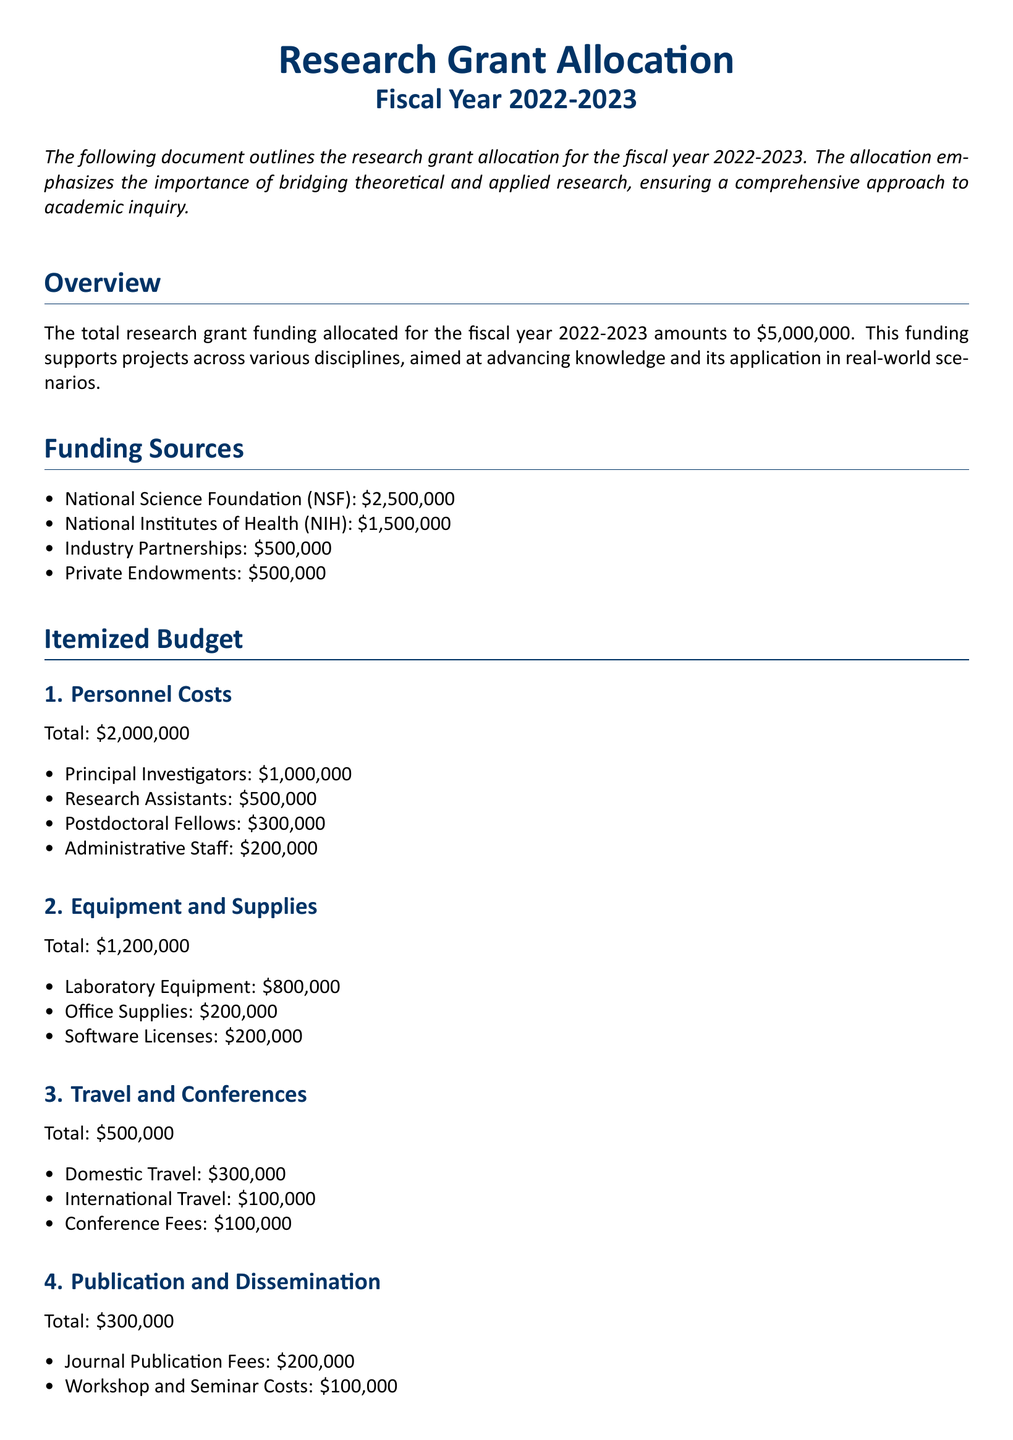What is the total funding allocated for fiscal year 2022-2023? The total funding allocation is stated clearly in the document.
Answer: $5,000,000 Who is the primary funding source? The first item listed under funding sources indicates which entity provides the most significant contribution.
Answer: National Science Foundation (NSF) How much is allocated to personnel costs? The itemized budget section provides a specific total for personnel costs.
Answer: $2,000,000 What amount is designated for travel and conferences? The total for travel and conferences is explicitly mentioned in the budget section of the document.
Answer: $500,000 Which category has the highest budget allocation? To determine this, one must compare the totals in the itemized budget for each category.
Answer: Personnel Costs What is the amount set aside for unexpected expenditures? The contingency fund section specifies the amount reserved for emergencies.
Answer: $200,000 How much funding comes from private endowments? The funding sources section lists the contribution from private endowments directly.
Answer: $500,000 What are the total publication costs? The document explicitly quantifies the total amount allocated for publication and dissemination.
Answer: $300,000 How much is allocated for institutional overhead? The itemized budget section details overhead costs, specifically indicating the relevant amount.
Answer: $800,000 What percentage of the total funding is contributed by NIH? To find this, one must calculate the percentage based on the total funding and the amount contributed by NIH.
Answer: 30% 